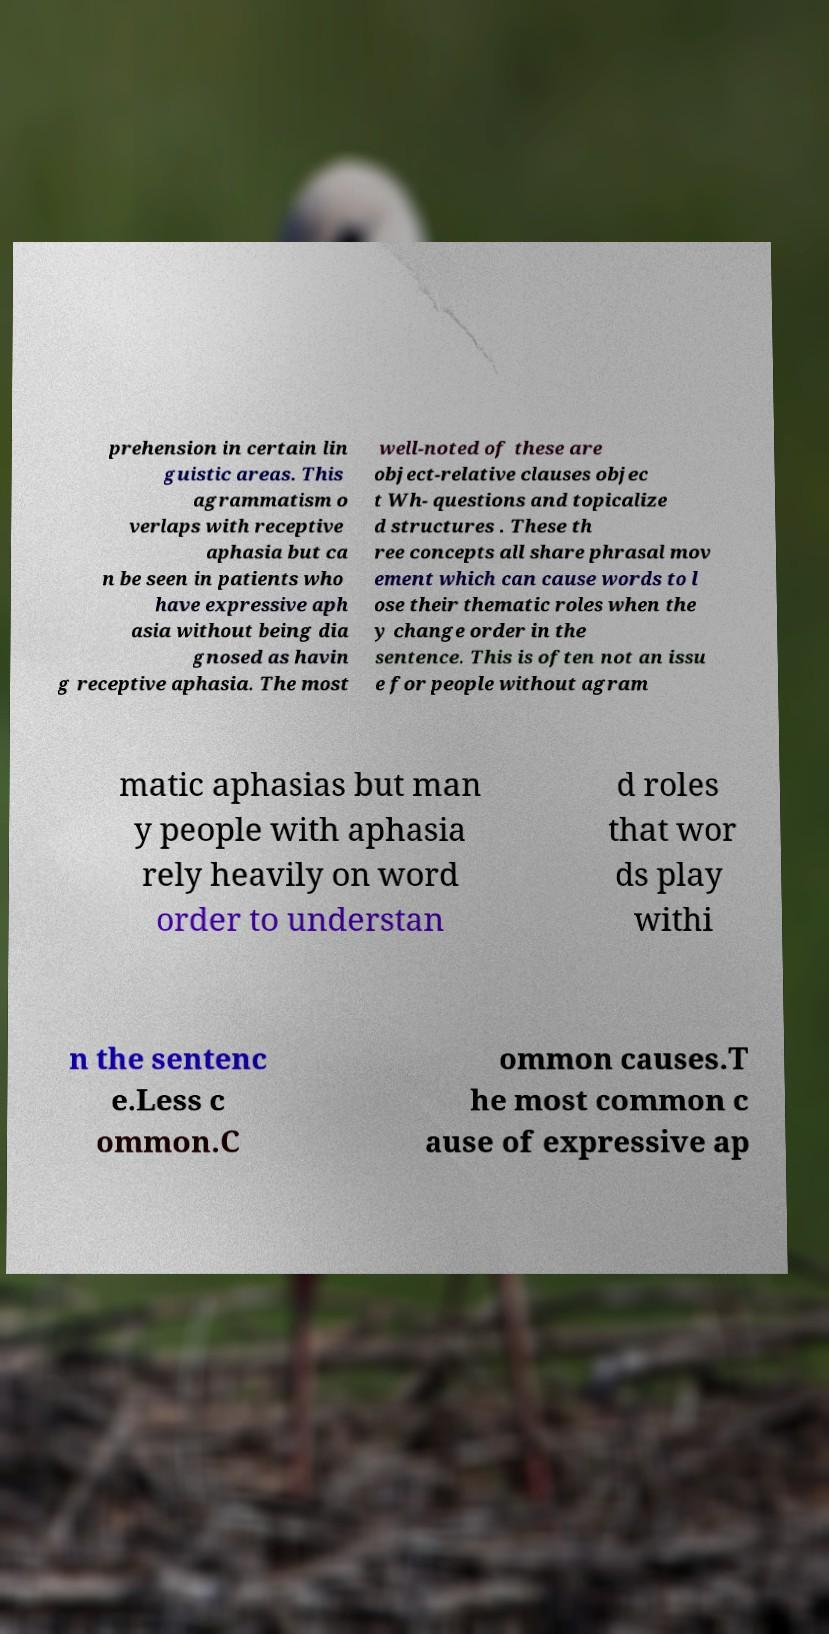I need the written content from this picture converted into text. Can you do that? prehension in certain lin guistic areas. This agrammatism o verlaps with receptive aphasia but ca n be seen in patients who have expressive aph asia without being dia gnosed as havin g receptive aphasia. The most well-noted of these are object-relative clauses objec t Wh- questions and topicalize d structures . These th ree concepts all share phrasal mov ement which can cause words to l ose their thematic roles when the y change order in the sentence. This is often not an issu e for people without agram matic aphasias but man y people with aphasia rely heavily on word order to understan d roles that wor ds play withi n the sentenc e.Less c ommon.C ommon causes.T he most common c ause of expressive ap 